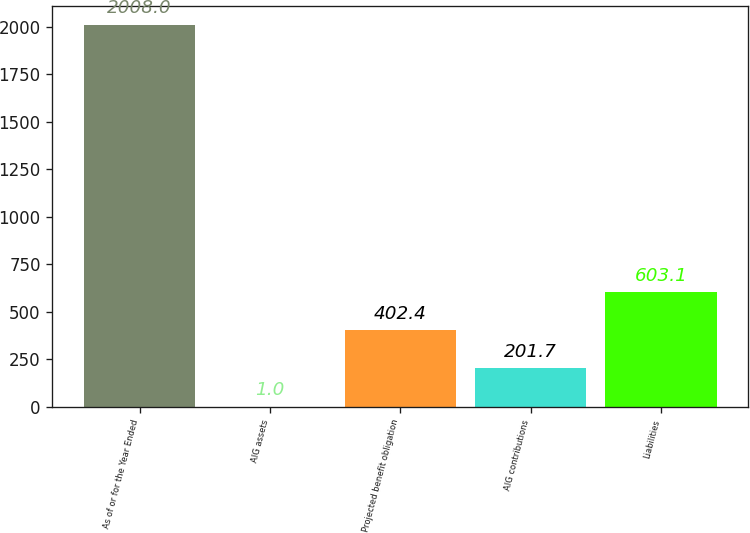<chart> <loc_0><loc_0><loc_500><loc_500><bar_chart><fcel>As of or for the Year Ended<fcel>AIG assets<fcel>Projected benefit obligation<fcel>AIG contributions<fcel>Liabilities<nl><fcel>2008<fcel>1<fcel>402.4<fcel>201.7<fcel>603.1<nl></chart> 